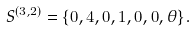<formula> <loc_0><loc_0><loc_500><loc_500>S ^ { ( 3 , 2 ) } = \{ 0 , 4 , 0 , 1 , 0 , 0 , \theta \} .</formula> 